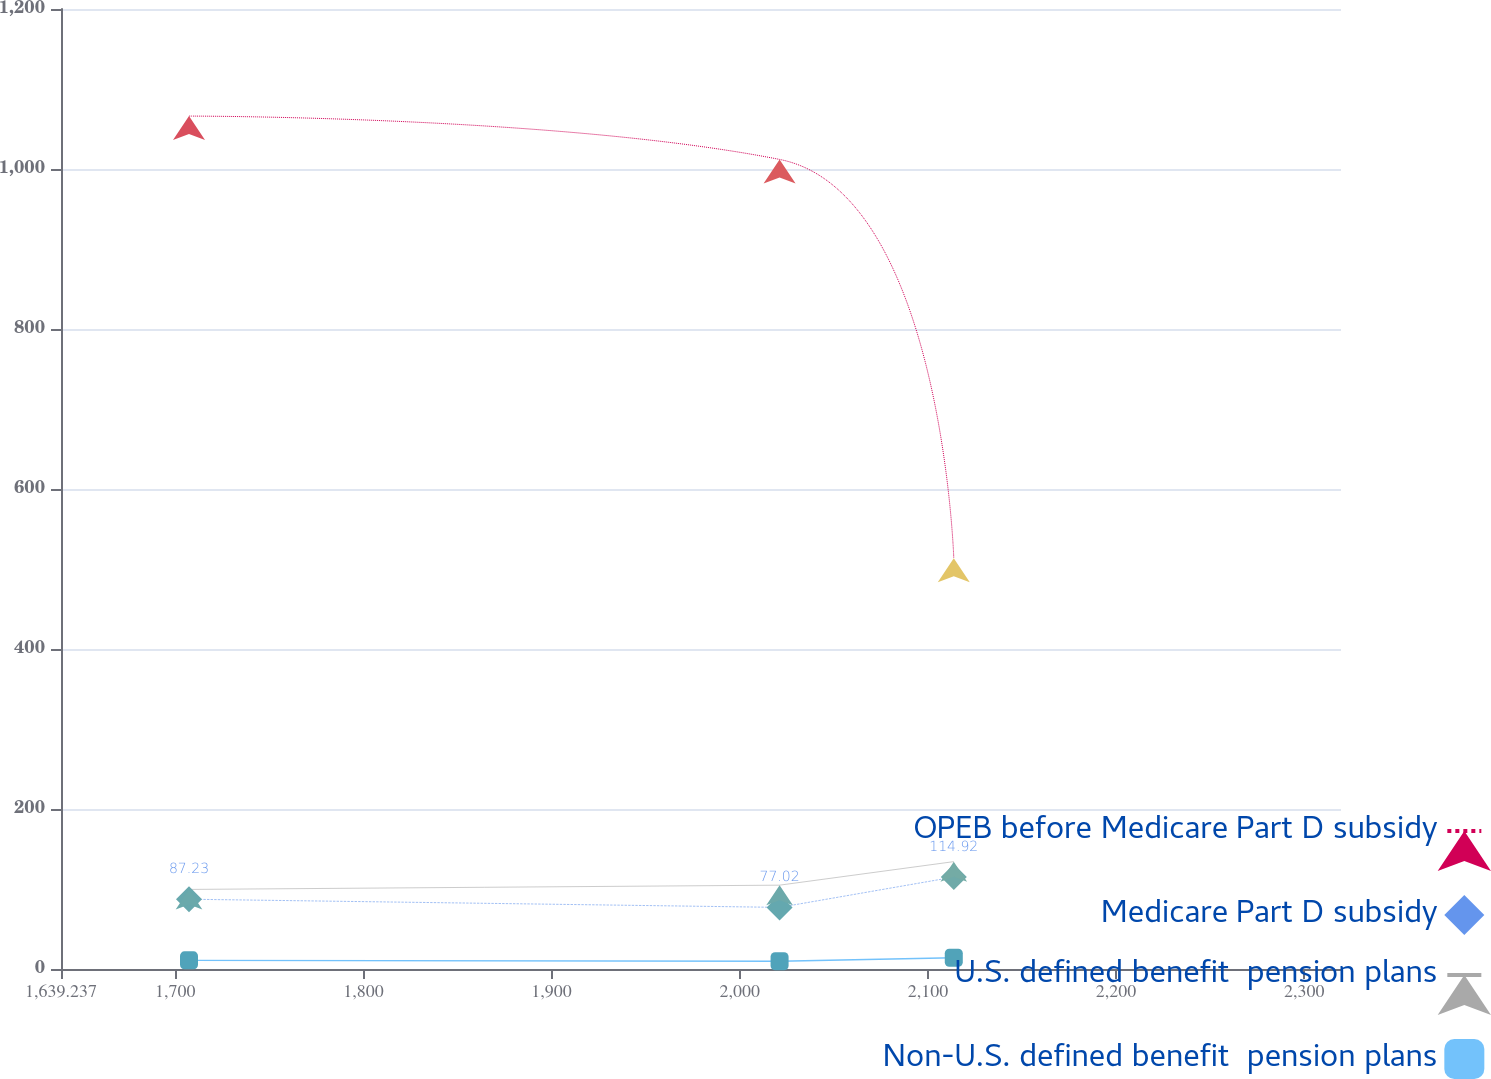Convert chart. <chart><loc_0><loc_0><loc_500><loc_500><line_chart><ecel><fcel>OPEB before Medicare Part D subsidy<fcel>Medicare Part D subsidy<fcel>U.S. defined benefit  pension plans<fcel>Non-U.S. defined benefit  pension plans<nl><fcel>1707.27<fcel>1066.14<fcel>87.23<fcel>99.47<fcel>10.81<nl><fcel>2021.17<fcel>1011.97<fcel>77.02<fcel>104.79<fcel>9.65<nl><fcel>2113.76<fcel>513.42<fcel>114.92<fcel>134.2<fcel>14.05<nl><fcel>2319.98<fcel>567.59<fcel>83.44<fcel>122.93<fcel>12.01<nl><fcel>2387.6<fcel>621.76<fcel>91.02<fcel>95.61<fcel>17.85<nl></chart> 